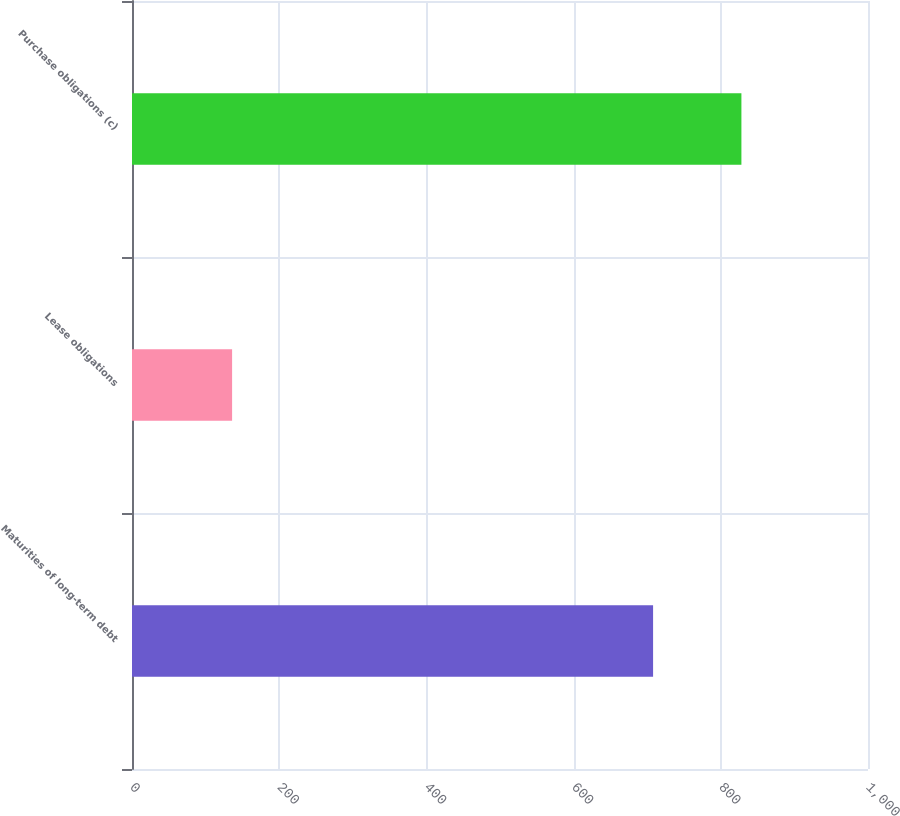Convert chart. <chart><loc_0><loc_0><loc_500><loc_500><bar_chart><fcel>Maturities of long-term debt<fcel>Lease obligations<fcel>Purchase obligations (c)<nl><fcel>708<fcel>136<fcel>828<nl></chart> 